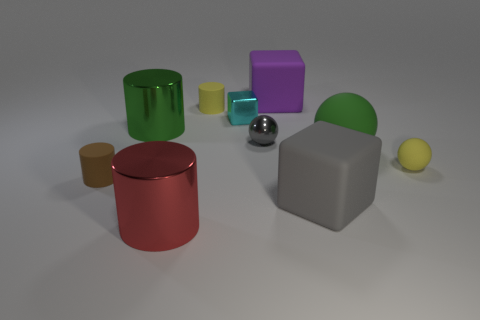Which objects in the image are touching each other? Based on the composition in the image, the red can and the purple block are in contact with each other. Additionally, the green sphere appears to be in light contact with the purple block. No other objects seem to be touching directly. 